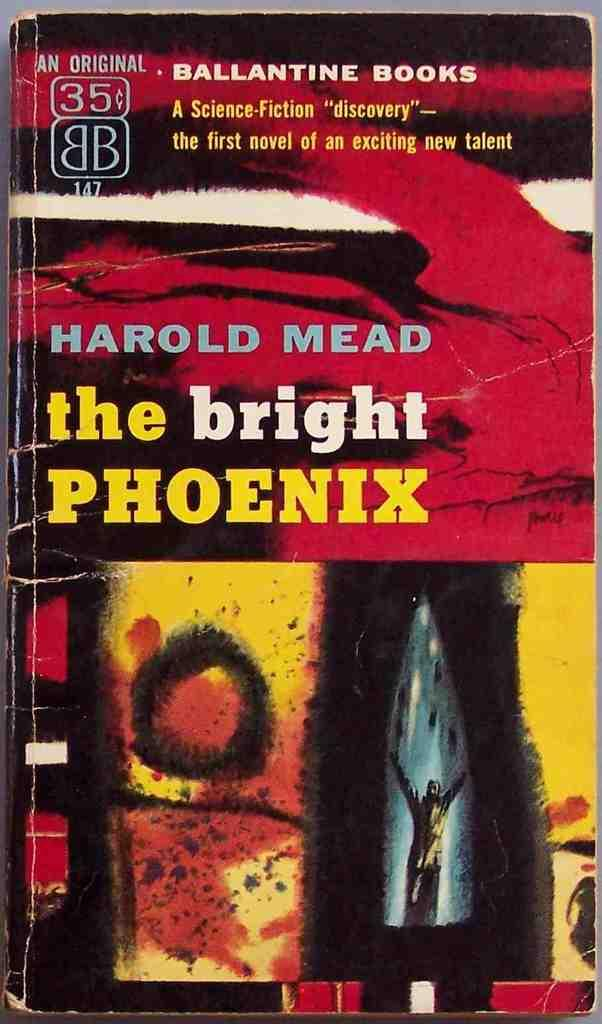<image>
Give a short and clear explanation of the subsequent image. The cover of The Bright Phoenix, and original from Ballantine books. 